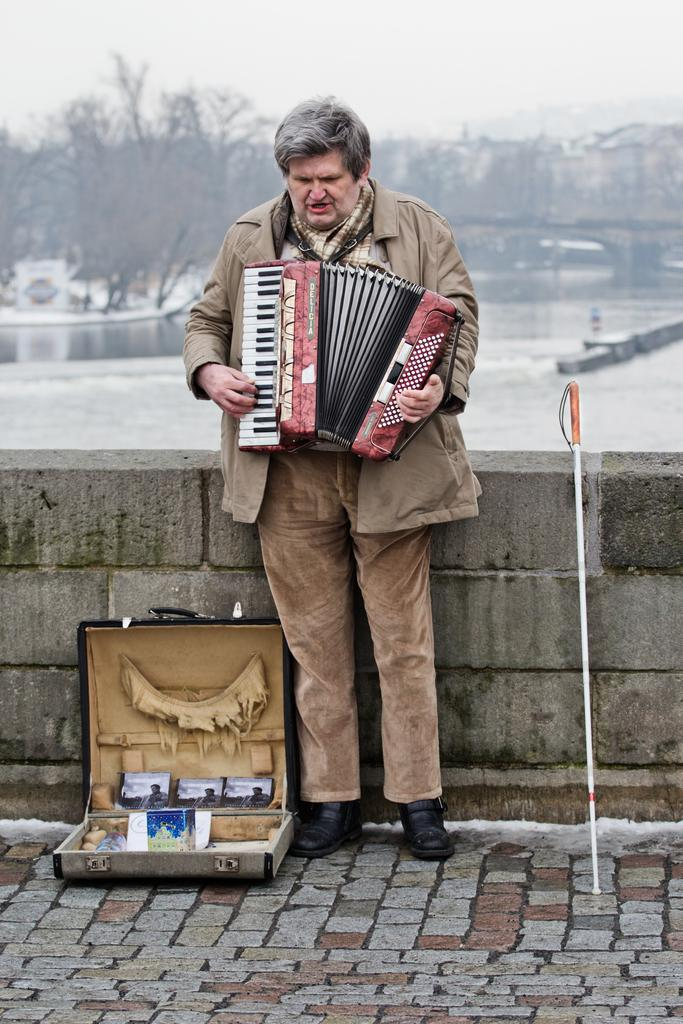What is the person in the image doing? There is a person playing a musical instrument in the image. What else can be seen in the image besides the person playing the instrument? There is a box with items in the image. What can be seen in the background of the image? There is a lake and trees visible in the background of the image. What type of operation is being performed on the musical instrument in the image? There is no operation being performed on the musical instrument in the image; the person is simply playing it. 